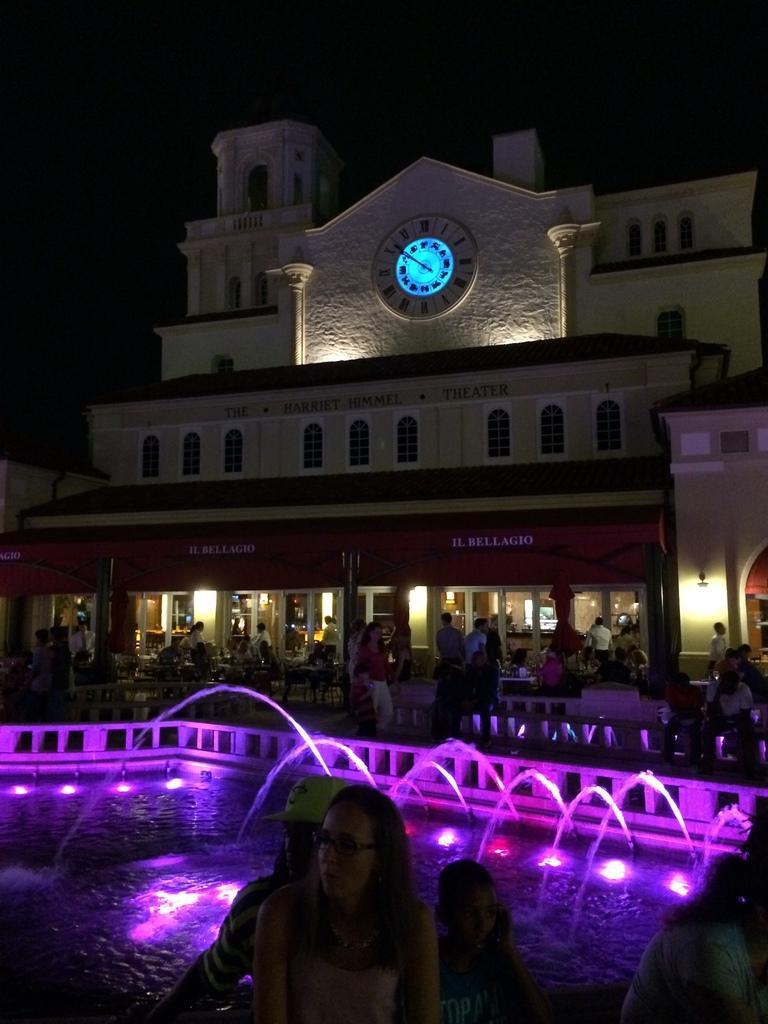Please provide a concise description of this image. Here we can see water, lights, and few people. There are chairs, tables, poles, boards, clock, and buildings. There is a dark background. 